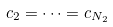Convert formula to latex. <formula><loc_0><loc_0><loc_500><loc_500>c _ { 2 } = \dots = c _ { N _ { 2 } }</formula> 